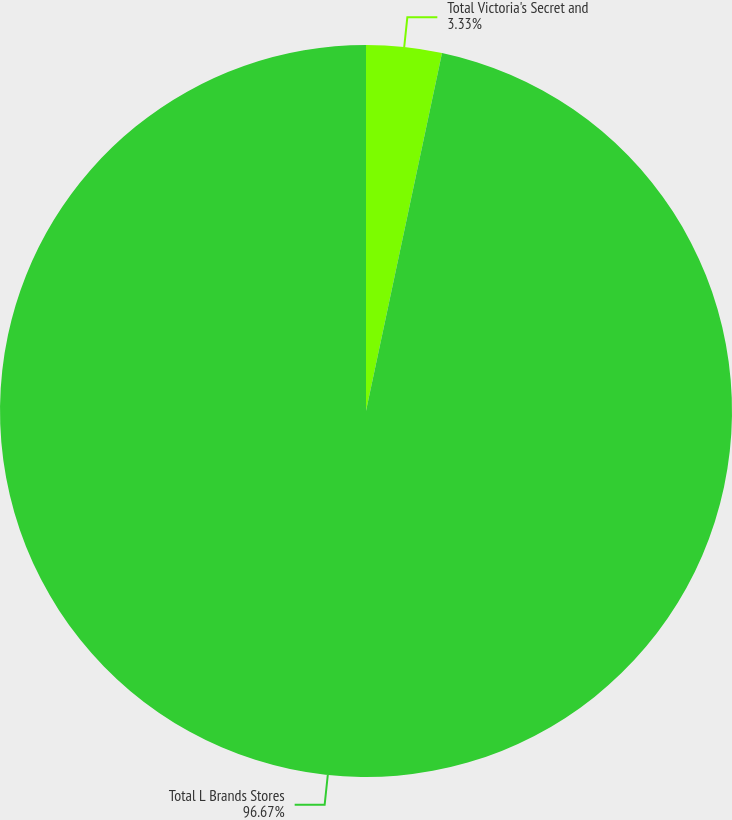Convert chart to OTSL. <chart><loc_0><loc_0><loc_500><loc_500><pie_chart><fcel>Total Victoria's Secret and<fcel>Total L Brands Stores<nl><fcel>3.33%<fcel>96.67%<nl></chart> 